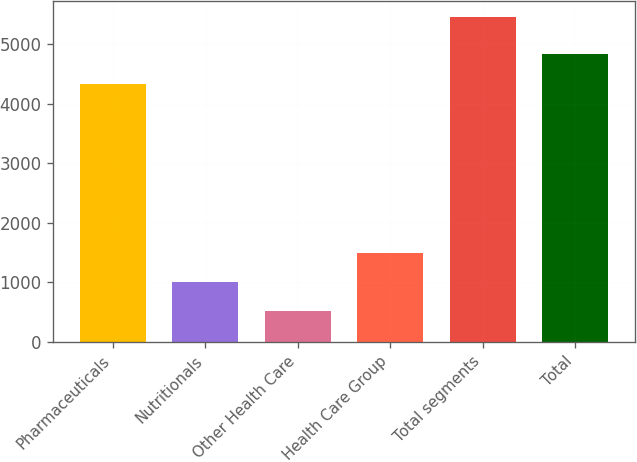Convert chart to OTSL. <chart><loc_0><loc_0><loc_500><loc_500><bar_chart><fcel>Pharmaceuticals<fcel>Nutritionals<fcel>Other Health Care<fcel>Health Care Group<fcel>Total segments<fcel>Total<nl><fcel>4334<fcel>1004.4<fcel>510<fcel>1498.8<fcel>5454<fcel>4828.4<nl></chart> 